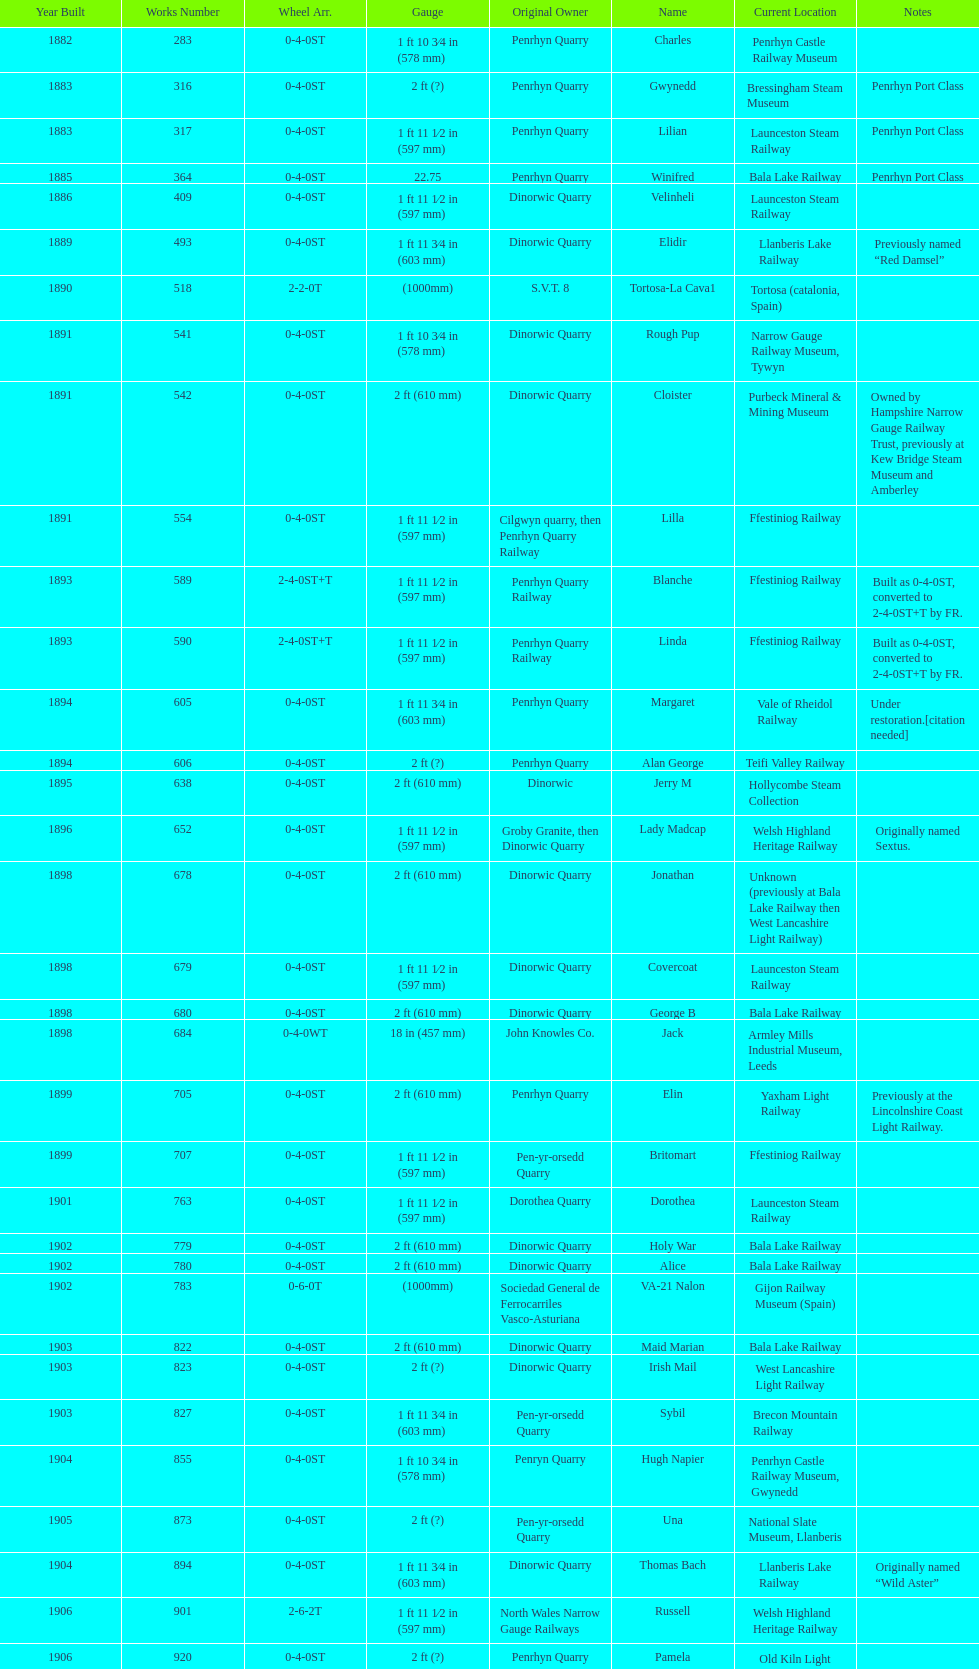Which initial proprietor possessed the most locomotives? Penrhyn Quarry. 